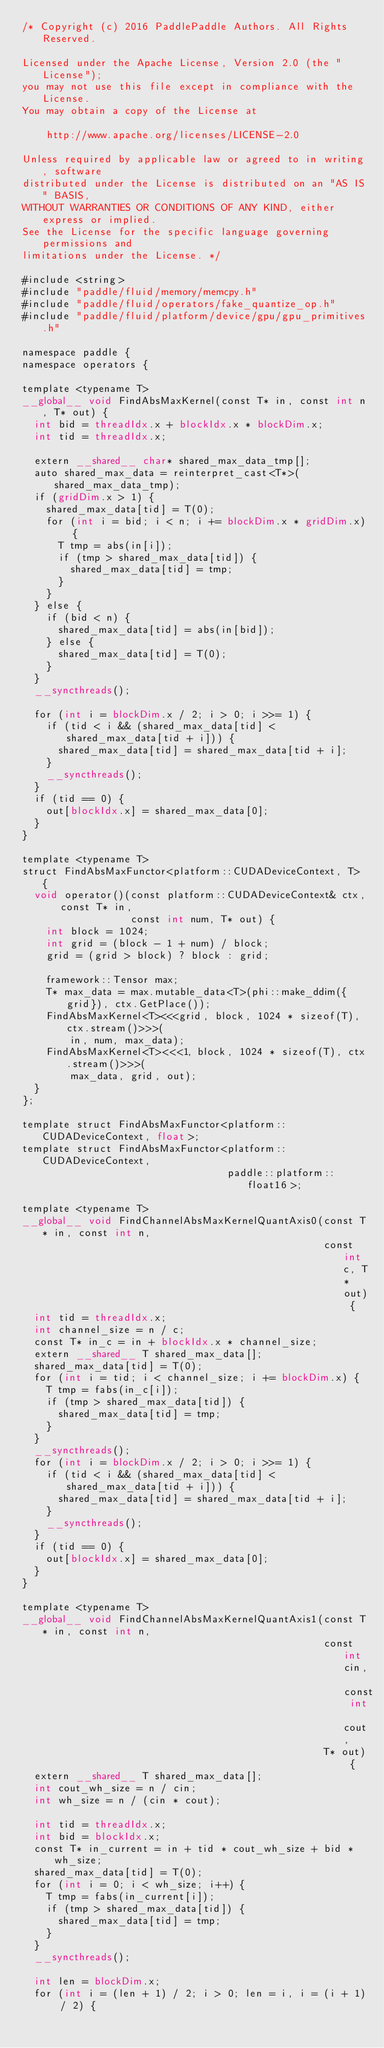Convert code to text. <code><loc_0><loc_0><loc_500><loc_500><_Cuda_>/* Copyright (c) 2016 PaddlePaddle Authors. All Rights Reserved.

Licensed under the Apache License, Version 2.0 (the "License");
you may not use this file except in compliance with the License.
You may obtain a copy of the License at

    http://www.apache.org/licenses/LICENSE-2.0

Unless required by applicable law or agreed to in writing, software
distributed under the License is distributed on an "AS IS" BASIS,
WITHOUT WARRANTIES OR CONDITIONS OF ANY KIND, either express or implied.
See the License for the specific language governing permissions and
limitations under the License. */

#include <string>
#include "paddle/fluid/memory/memcpy.h"
#include "paddle/fluid/operators/fake_quantize_op.h"
#include "paddle/fluid/platform/device/gpu/gpu_primitives.h"

namespace paddle {
namespace operators {

template <typename T>
__global__ void FindAbsMaxKernel(const T* in, const int n, T* out) {
  int bid = threadIdx.x + blockIdx.x * blockDim.x;
  int tid = threadIdx.x;

  extern __shared__ char* shared_max_data_tmp[];
  auto shared_max_data = reinterpret_cast<T*>(shared_max_data_tmp);
  if (gridDim.x > 1) {
    shared_max_data[tid] = T(0);
    for (int i = bid; i < n; i += blockDim.x * gridDim.x) {
      T tmp = abs(in[i]);
      if (tmp > shared_max_data[tid]) {
        shared_max_data[tid] = tmp;
      }
    }
  } else {
    if (bid < n) {
      shared_max_data[tid] = abs(in[bid]);
    } else {
      shared_max_data[tid] = T(0);
    }
  }
  __syncthreads();

  for (int i = blockDim.x / 2; i > 0; i >>= 1) {
    if (tid < i && (shared_max_data[tid] < shared_max_data[tid + i])) {
      shared_max_data[tid] = shared_max_data[tid + i];
    }
    __syncthreads();
  }
  if (tid == 0) {
    out[blockIdx.x] = shared_max_data[0];
  }
}

template <typename T>
struct FindAbsMaxFunctor<platform::CUDADeviceContext, T> {
  void operator()(const platform::CUDADeviceContext& ctx, const T* in,
                  const int num, T* out) {
    int block = 1024;
    int grid = (block - 1 + num) / block;
    grid = (grid > block) ? block : grid;

    framework::Tensor max;
    T* max_data = max.mutable_data<T>(phi::make_ddim({grid}), ctx.GetPlace());
    FindAbsMaxKernel<T><<<grid, block, 1024 * sizeof(T), ctx.stream()>>>(
        in, num, max_data);
    FindAbsMaxKernel<T><<<1, block, 1024 * sizeof(T), ctx.stream()>>>(
        max_data, grid, out);
  }
};

template struct FindAbsMaxFunctor<platform::CUDADeviceContext, float>;
template struct FindAbsMaxFunctor<platform::CUDADeviceContext,
                                  paddle::platform::float16>;

template <typename T>
__global__ void FindChannelAbsMaxKernelQuantAxis0(const T* in, const int n,
                                                  const int c, T* out) {
  int tid = threadIdx.x;
  int channel_size = n / c;
  const T* in_c = in + blockIdx.x * channel_size;
  extern __shared__ T shared_max_data[];
  shared_max_data[tid] = T(0);
  for (int i = tid; i < channel_size; i += blockDim.x) {
    T tmp = fabs(in_c[i]);
    if (tmp > shared_max_data[tid]) {
      shared_max_data[tid] = tmp;
    }
  }
  __syncthreads();
  for (int i = blockDim.x / 2; i > 0; i >>= 1) {
    if (tid < i && (shared_max_data[tid] < shared_max_data[tid + i])) {
      shared_max_data[tid] = shared_max_data[tid + i];
    }
    __syncthreads();
  }
  if (tid == 0) {
    out[blockIdx.x] = shared_max_data[0];
  }
}

template <typename T>
__global__ void FindChannelAbsMaxKernelQuantAxis1(const T* in, const int n,
                                                  const int cin, const int cout,
                                                  T* out) {
  extern __shared__ T shared_max_data[];
  int cout_wh_size = n / cin;
  int wh_size = n / (cin * cout);

  int tid = threadIdx.x;
  int bid = blockIdx.x;
  const T* in_current = in + tid * cout_wh_size + bid * wh_size;
  shared_max_data[tid] = T(0);
  for (int i = 0; i < wh_size; i++) {
    T tmp = fabs(in_current[i]);
    if (tmp > shared_max_data[tid]) {
      shared_max_data[tid] = tmp;
    }
  }
  __syncthreads();

  int len = blockDim.x;
  for (int i = (len + 1) / 2; i > 0; len = i, i = (i + 1) / 2) {</code> 